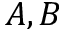<formula> <loc_0><loc_0><loc_500><loc_500>A , B</formula> 